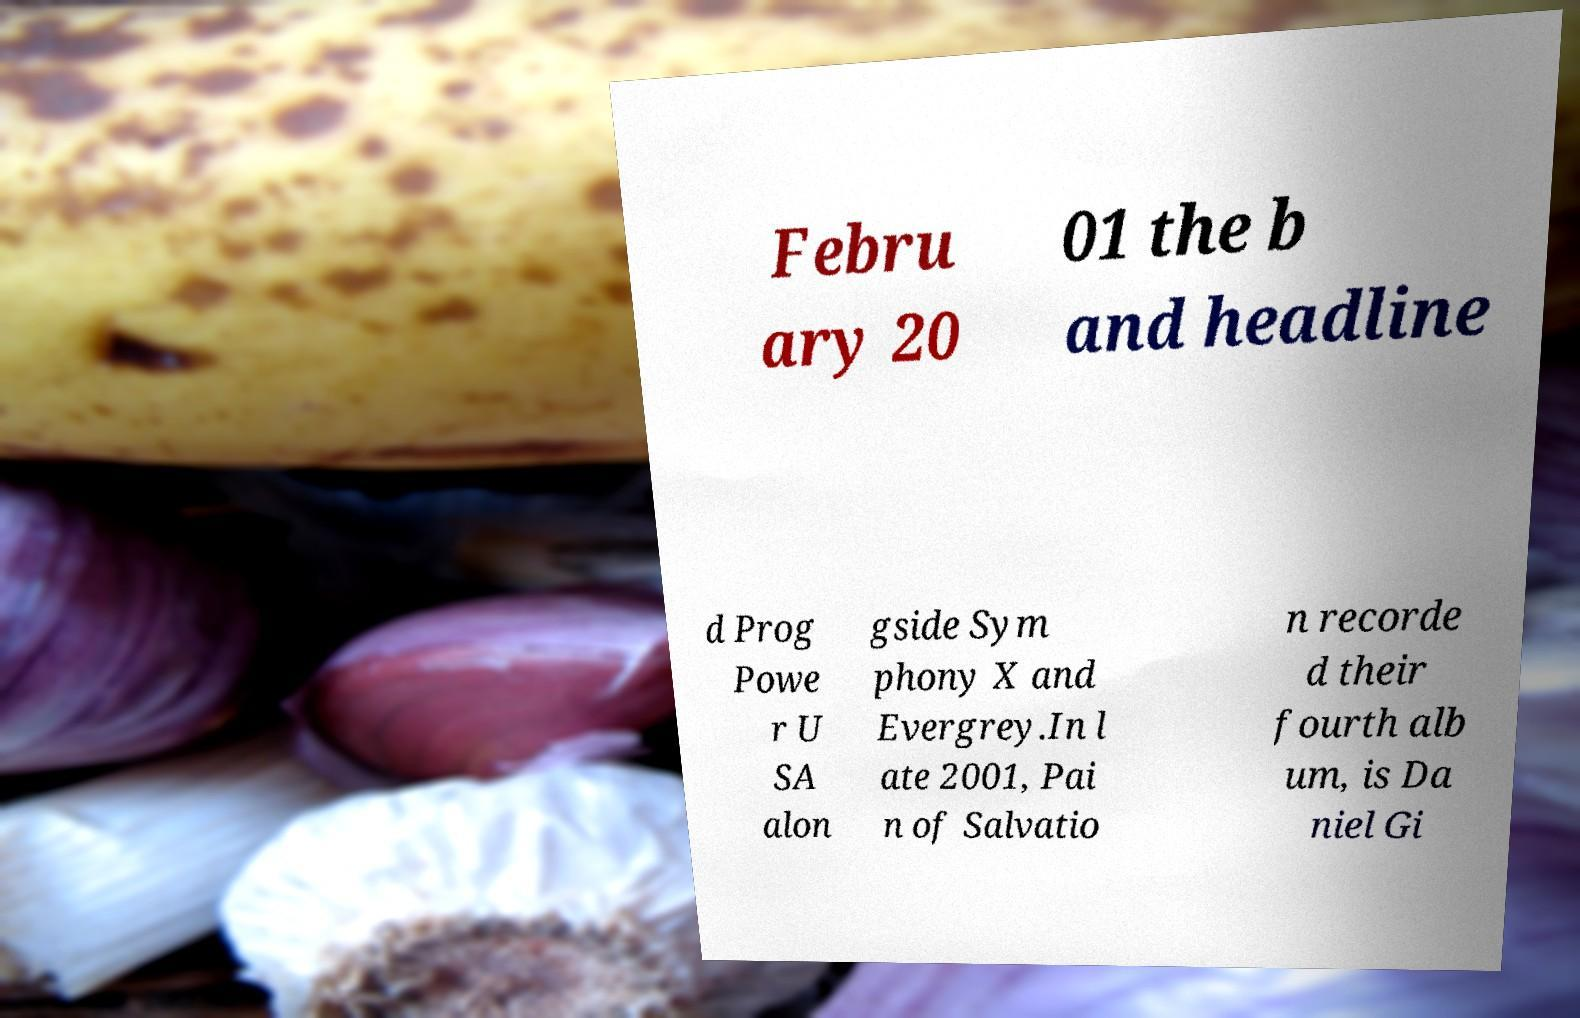What messages or text are displayed in this image? I need them in a readable, typed format. Febru ary 20 01 the b and headline d Prog Powe r U SA alon gside Sym phony X and Evergrey.In l ate 2001, Pai n of Salvatio n recorde d their fourth alb um, is Da niel Gi 